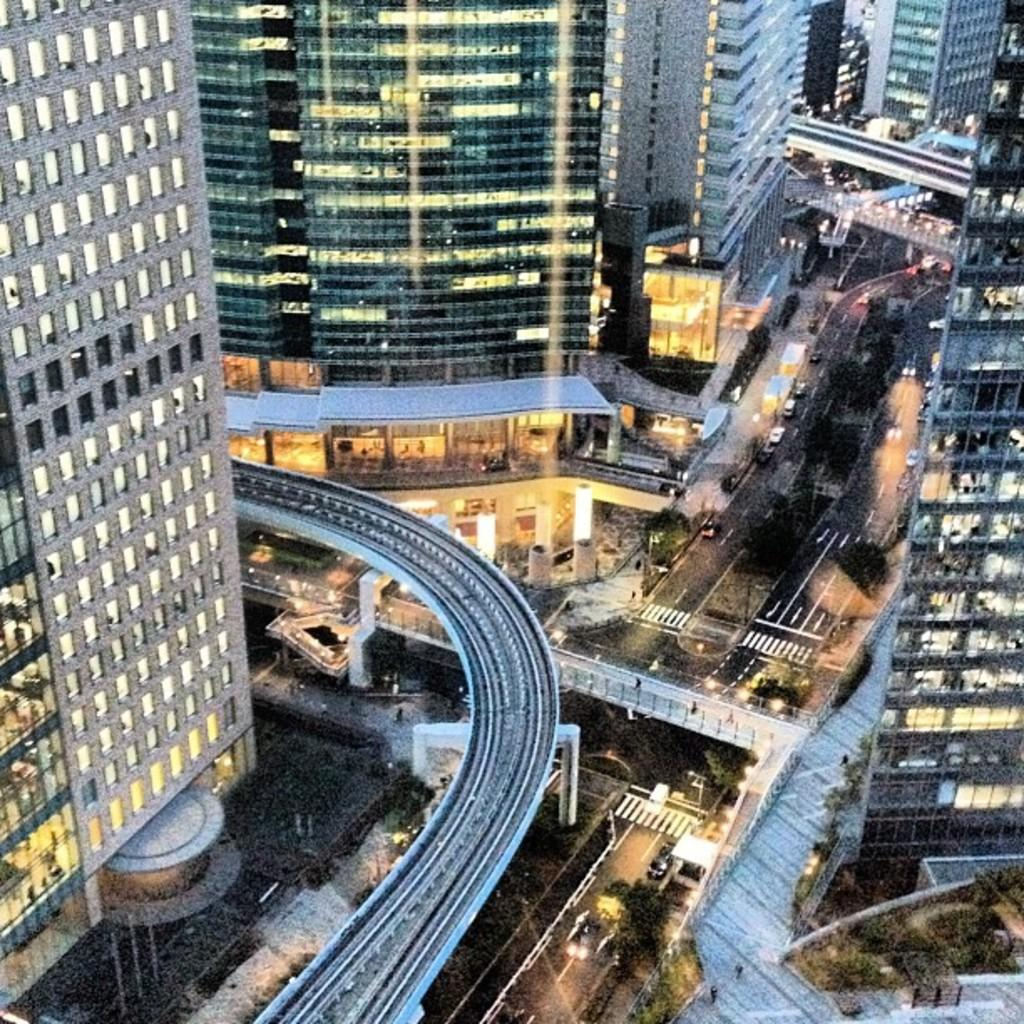What type of buildings can be seen in the image? There are skyscrapers in the image. What natural elements are present in the image? There are trees in the image. What structures can be seen in the image? There are poles and bridges in the image. What is happening on the road in the image? There are vehicles on the road in the image. What can be seen illuminated in the image? There are lights visible in the image. Are there any people present in the image? Yes, people are visible in the image. What type of sidewalk is visible in the image? There is no sidewalk present in the image. What thought or idea is being expressed by the trees in the image? Trees do not express thoughts or ideas; they are natural elements in the image. 